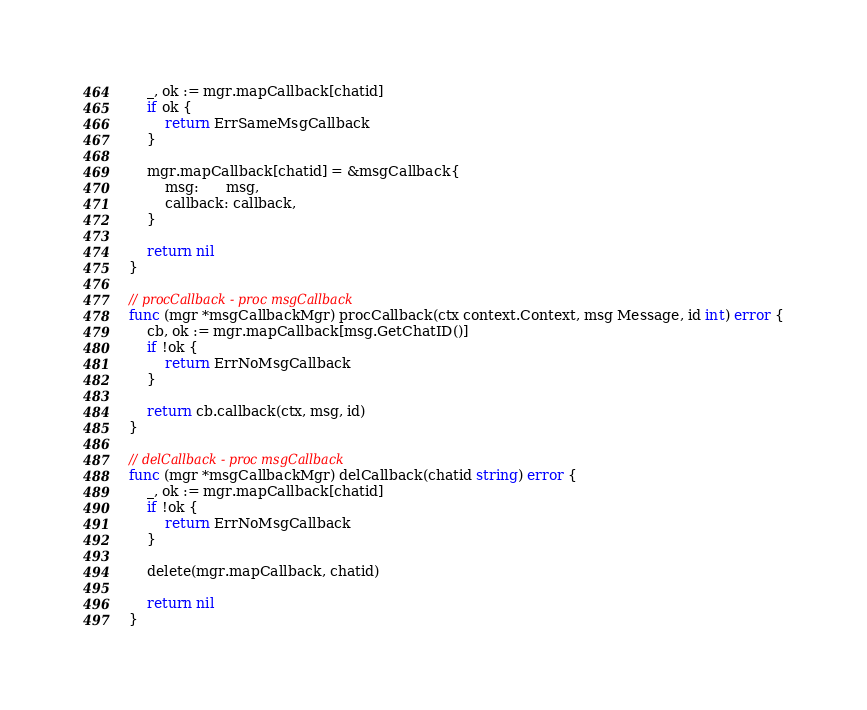Convert code to text. <code><loc_0><loc_0><loc_500><loc_500><_Go_>	_, ok := mgr.mapCallback[chatid]
	if ok {
		return ErrSameMsgCallback
	}

	mgr.mapCallback[chatid] = &msgCallback{
		msg:      msg,
		callback: callback,
	}

	return nil
}

// procCallback - proc msgCallback
func (mgr *msgCallbackMgr) procCallback(ctx context.Context, msg Message, id int) error {
	cb, ok := mgr.mapCallback[msg.GetChatID()]
	if !ok {
		return ErrNoMsgCallback
	}

	return cb.callback(ctx, msg, id)
}

// delCallback - proc msgCallback
func (mgr *msgCallbackMgr) delCallback(chatid string) error {
	_, ok := mgr.mapCallback[chatid]
	if !ok {
		return ErrNoMsgCallback
	}

	delete(mgr.mapCallback, chatid)

	return nil
}
</code> 